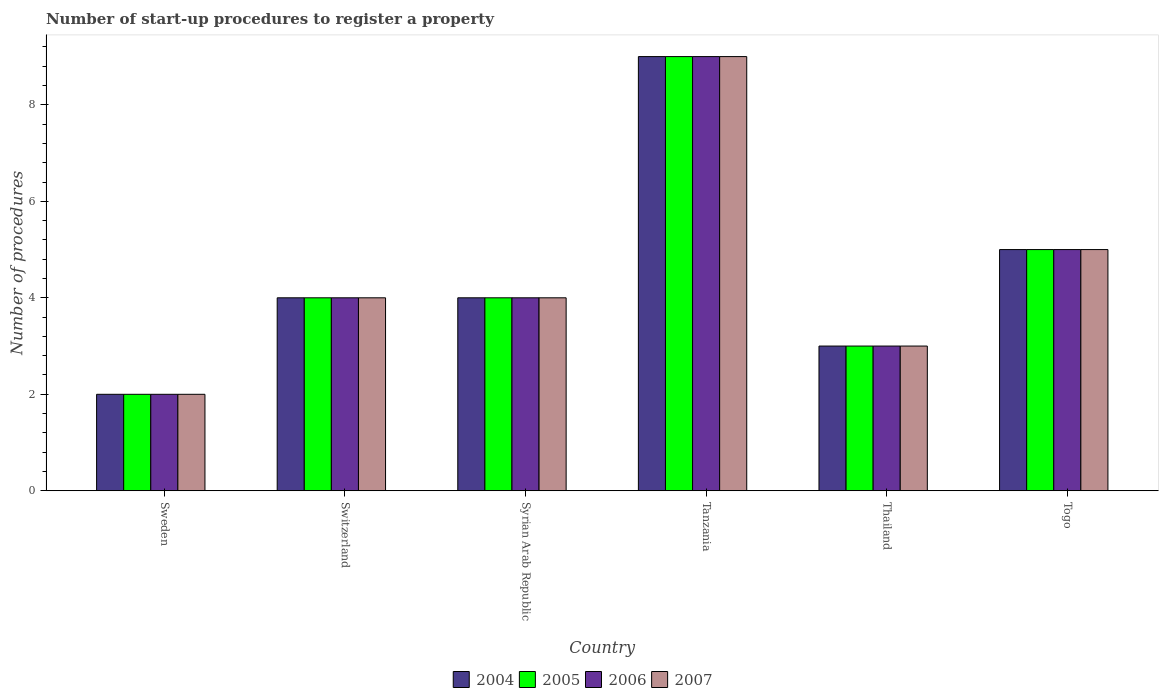Are the number of bars on each tick of the X-axis equal?
Provide a succinct answer. Yes. How many bars are there on the 3rd tick from the right?
Give a very brief answer. 4. What is the number of procedures required to register a property in 2004 in Sweden?
Keep it short and to the point. 2. In which country was the number of procedures required to register a property in 2006 maximum?
Keep it short and to the point. Tanzania. What is the difference between the number of procedures required to register a property in 2004 in Syrian Arab Republic and that in Tanzania?
Give a very brief answer. -5. What is the difference between the number of procedures required to register a property in 2007 in Tanzania and the number of procedures required to register a property in 2006 in Switzerland?
Your answer should be very brief. 5. What is the difference between the highest and the second highest number of procedures required to register a property in 2006?
Ensure brevity in your answer.  5. Is the sum of the number of procedures required to register a property in 2006 in Sweden and Thailand greater than the maximum number of procedures required to register a property in 2005 across all countries?
Keep it short and to the point. No. Is it the case that in every country, the sum of the number of procedures required to register a property in 2007 and number of procedures required to register a property in 2004 is greater than the sum of number of procedures required to register a property in 2006 and number of procedures required to register a property in 2005?
Make the answer very short. No. Is it the case that in every country, the sum of the number of procedures required to register a property in 2006 and number of procedures required to register a property in 2005 is greater than the number of procedures required to register a property in 2004?
Provide a short and direct response. Yes. How many countries are there in the graph?
Your response must be concise. 6. Does the graph contain any zero values?
Provide a succinct answer. No. Does the graph contain grids?
Ensure brevity in your answer.  No. Where does the legend appear in the graph?
Give a very brief answer. Bottom center. What is the title of the graph?
Make the answer very short. Number of start-up procedures to register a property. What is the label or title of the Y-axis?
Provide a succinct answer. Number of procedures. What is the Number of procedures in 2004 in Sweden?
Offer a terse response. 2. What is the Number of procedures in 2005 in Sweden?
Provide a succinct answer. 2. What is the Number of procedures of 2006 in Sweden?
Make the answer very short. 2. What is the Number of procedures of 2004 in Switzerland?
Give a very brief answer. 4. What is the Number of procedures of 2006 in Switzerland?
Keep it short and to the point. 4. What is the Number of procedures of 2007 in Switzerland?
Offer a very short reply. 4. What is the Number of procedures in 2007 in Syrian Arab Republic?
Provide a short and direct response. 4. What is the Number of procedures of 2007 in Tanzania?
Keep it short and to the point. 9. What is the Number of procedures in 2004 in Thailand?
Keep it short and to the point. 3. What is the Number of procedures in 2005 in Thailand?
Provide a short and direct response. 3. What is the Number of procedures of 2005 in Togo?
Provide a short and direct response. 5. What is the Number of procedures in 2006 in Togo?
Provide a short and direct response. 5. What is the Number of procedures in 2007 in Togo?
Provide a short and direct response. 5. Across all countries, what is the maximum Number of procedures of 2004?
Ensure brevity in your answer.  9. Across all countries, what is the maximum Number of procedures in 2006?
Keep it short and to the point. 9. Across all countries, what is the minimum Number of procedures of 2004?
Your answer should be very brief. 2. Across all countries, what is the minimum Number of procedures of 2006?
Your answer should be very brief. 2. Across all countries, what is the minimum Number of procedures in 2007?
Provide a succinct answer. 2. What is the total Number of procedures of 2004 in the graph?
Provide a short and direct response. 27. What is the total Number of procedures of 2006 in the graph?
Give a very brief answer. 27. What is the difference between the Number of procedures in 2004 in Sweden and that in Switzerland?
Offer a very short reply. -2. What is the difference between the Number of procedures in 2006 in Sweden and that in Switzerland?
Your answer should be compact. -2. What is the difference between the Number of procedures in 2006 in Sweden and that in Syrian Arab Republic?
Offer a very short reply. -2. What is the difference between the Number of procedures of 2007 in Sweden and that in Syrian Arab Republic?
Make the answer very short. -2. What is the difference between the Number of procedures of 2004 in Sweden and that in Tanzania?
Your answer should be very brief. -7. What is the difference between the Number of procedures in 2006 in Sweden and that in Tanzania?
Keep it short and to the point. -7. What is the difference between the Number of procedures in 2007 in Sweden and that in Tanzania?
Offer a very short reply. -7. What is the difference between the Number of procedures of 2004 in Sweden and that in Thailand?
Your answer should be very brief. -1. What is the difference between the Number of procedures in 2005 in Sweden and that in Thailand?
Give a very brief answer. -1. What is the difference between the Number of procedures in 2004 in Sweden and that in Togo?
Make the answer very short. -3. What is the difference between the Number of procedures of 2005 in Sweden and that in Togo?
Your response must be concise. -3. What is the difference between the Number of procedures of 2005 in Switzerland and that in Syrian Arab Republic?
Make the answer very short. 0. What is the difference between the Number of procedures in 2004 in Switzerland and that in Tanzania?
Provide a succinct answer. -5. What is the difference between the Number of procedures in 2004 in Switzerland and that in Thailand?
Ensure brevity in your answer.  1. What is the difference between the Number of procedures in 2005 in Switzerland and that in Thailand?
Your answer should be very brief. 1. What is the difference between the Number of procedures in 2006 in Switzerland and that in Thailand?
Offer a terse response. 1. What is the difference between the Number of procedures of 2004 in Switzerland and that in Togo?
Offer a very short reply. -1. What is the difference between the Number of procedures in 2005 in Switzerland and that in Togo?
Offer a very short reply. -1. What is the difference between the Number of procedures in 2006 in Switzerland and that in Togo?
Ensure brevity in your answer.  -1. What is the difference between the Number of procedures of 2004 in Syrian Arab Republic and that in Tanzania?
Your answer should be compact. -5. What is the difference between the Number of procedures of 2006 in Syrian Arab Republic and that in Tanzania?
Ensure brevity in your answer.  -5. What is the difference between the Number of procedures in 2005 in Syrian Arab Republic and that in Thailand?
Provide a succinct answer. 1. What is the difference between the Number of procedures in 2006 in Syrian Arab Republic and that in Thailand?
Offer a very short reply. 1. What is the difference between the Number of procedures of 2004 in Syrian Arab Republic and that in Togo?
Your response must be concise. -1. What is the difference between the Number of procedures of 2005 in Syrian Arab Republic and that in Togo?
Your answer should be very brief. -1. What is the difference between the Number of procedures in 2006 in Syrian Arab Republic and that in Togo?
Offer a terse response. -1. What is the difference between the Number of procedures in 2006 in Tanzania and that in Thailand?
Provide a succinct answer. 6. What is the difference between the Number of procedures of 2007 in Tanzania and that in Thailand?
Your response must be concise. 6. What is the difference between the Number of procedures of 2005 in Tanzania and that in Togo?
Your answer should be compact. 4. What is the difference between the Number of procedures in 2004 in Thailand and that in Togo?
Make the answer very short. -2. What is the difference between the Number of procedures in 2006 in Thailand and that in Togo?
Make the answer very short. -2. What is the difference between the Number of procedures in 2007 in Thailand and that in Togo?
Your response must be concise. -2. What is the difference between the Number of procedures of 2004 in Sweden and the Number of procedures of 2006 in Switzerland?
Offer a terse response. -2. What is the difference between the Number of procedures in 2004 in Sweden and the Number of procedures in 2007 in Switzerland?
Offer a terse response. -2. What is the difference between the Number of procedures of 2005 in Sweden and the Number of procedures of 2006 in Switzerland?
Ensure brevity in your answer.  -2. What is the difference between the Number of procedures of 2005 in Sweden and the Number of procedures of 2007 in Switzerland?
Make the answer very short. -2. What is the difference between the Number of procedures of 2004 in Sweden and the Number of procedures of 2005 in Syrian Arab Republic?
Ensure brevity in your answer.  -2. What is the difference between the Number of procedures in 2004 in Sweden and the Number of procedures in 2006 in Syrian Arab Republic?
Keep it short and to the point. -2. What is the difference between the Number of procedures in 2005 in Sweden and the Number of procedures in 2006 in Syrian Arab Republic?
Ensure brevity in your answer.  -2. What is the difference between the Number of procedures in 2005 in Sweden and the Number of procedures in 2007 in Syrian Arab Republic?
Keep it short and to the point. -2. What is the difference between the Number of procedures of 2006 in Sweden and the Number of procedures of 2007 in Syrian Arab Republic?
Your response must be concise. -2. What is the difference between the Number of procedures of 2004 in Sweden and the Number of procedures of 2006 in Tanzania?
Ensure brevity in your answer.  -7. What is the difference between the Number of procedures of 2005 in Sweden and the Number of procedures of 2006 in Tanzania?
Provide a short and direct response. -7. What is the difference between the Number of procedures of 2006 in Sweden and the Number of procedures of 2007 in Tanzania?
Give a very brief answer. -7. What is the difference between the Number of procedures of 2004 in Sweden and the Number of procedures of 2006 in Thailand?
Provide a short and direct response. -1. What is the difference between the Number of procedures of 2005 in Sweden and the Number of procedures of 2006 in Thailand?
Keep it short and to the point. -1. What is the difference between the Number of procedures of 2005 in Sweden and the Number of procedures of 2007 in Thailand?
Give a very brief answer. -1. What is the difference between the Number of procedures in 2004 in Sweden and the Number of procedures in 2006 in Togo?
Provide a succinct answer. -3. What is the difference between the Number of procedures in 2005 in Sweden and the Number of procedures in 2006 in Togo?
Provide a succinct answer. -3. What is the difference between the Number of procedures of 2004 in Switzerland and the Number of procedures of 2005 in Syrian Arab Republic?
Give a very brief answer. 0. What is the difference between the Number of procedures in 2004 in Switzerland and the Number of procedures in 2007 in Syrian Arab Republic?
Give a very brief answer. 0. What is the difference between the Number of procedures in 2004 in Switzerland and the Number of procedures in 2007 in Tanzania?
Ensure brevity in your answer.  -5. What is the difference between the Number of procedures in 2005 in Switzerland and the Number of procedures in 2006 in Tanzania?
Provide a succinct answer. -5. What is the difference between the Number of procedures in 2006 in Switzerland and the Number of procedures in 2007 in Tanzania?
Make the answer very short. -5. What is the difference between the Number of procedures of 2004 in Switzerland and the Number of procedures of 2007 in Thailand?
Your answer should be very brief. 1. What is the difference between the Number of procedures of 2005 in Switzerland and the Number of procedures of 2006 in Thailand?
Ensure brevity in your answer.  1. What is the difference between the Number of procedures of 2004 in Switzerland and the Number of procedures of 2006 in Togo?
Offer a terse response. -1. What is the difference between the Number of procedures of 2005 in Switzerland and the Number of procedures of 2006 in Togo?
Offer a very short reply. -1. What is the difference between the Number of procedures of 2006 in Switzerland and the Number of procedures of 2007 in Togo?
Provide a short and direct response. -1. What is the difference between the Number of procedures of 2004 in Syrian Arab Republic and the Number of procedures of 2006 in Tanzania?
Provide a succinct answer. -5. What is the difference between the Number of procedures in 2005 in Syrian Arab Republic and the Number of procedures in 2007 in Tanzania?
Offer a very short reply. -5. What is the difference between the Number of procedures in 2006 in Syrian Arab Republic and the Number of procedures in 2007 in Tanzania?
Offer a terse response. -5. What is the difference between the Number of procedures in 2004 in Syrian Arab Republic and the Number of procedures in 2005 in Thailand?
Keep it short and to the point. 1. What is the difference between the Number of procedures of 2005 in Syrian Arab Republic and the Number of procedures of 2006 in Thailand?
Offer a very short reply. 1. What is the difference between the Number of procedures in 2005 in Syrian Arab Republic and the Number of procedures in 2007 in Thailand?
Make the answer very short. 1. What is the difference between the Number of procedures of 2006 in Syrian Arab Republic and the Number of procedures of 2007 in Thailand?
Your response must be concise. 1. What is the difference between the Number of procedures in 2004 in Syrian Arab Republic and the Number of procedures in 2005 in Togo?
Your answer should be compact. -1. What is the difference between the Number of procedures of 2004 in Syrian Arab Republic and the Number of procedures of 2006 in Togo?
Provide a succinct answer. -1. What is the difference between the Number of procedures of 2005 in Syrian Arab Republic and the Number of procedures of 2007 in Togo?
Your response must be concise. -1. What is the difference between the Number of procedures in 2004 in Tanzania and the Number of procedures in 2005 in Thailand?
Your answer should be compact. 6. What is the difference between the Number of procedures of 2004 in Tanzania and the Number of procedures of 2006 in Thailand?
Provide a succinct answer. 6. What is the difference between the Number of procedures of 2005 in Tanzania and the Number of procedures of 2006 in Thailand?
Offer a very short reply. 6. What is the difference between the Number of procedures of 2006 in Tanzania and the Number of procedures of 2007 in Thailand?
Give a very brief answer. 6. What is the difference between the Number of procedures in 2004 in Tanzania and the Number of procedures in 2005 in Togo?
Offer a terse response. 4. What is the difference between the Number of procedures in 2004 in Tanzania and the Number of procedures in 2006 in Togo?
Provide a short and direct response. 4. What is the difference between the Number of procedures in 2005 in Tanzania and the Number of procedures in 2006 in Togo?
Offer a very short reply. 4. What is the difference between the Number of procedures of 2005 in Tanzania and the Number of procedures of 2007 in Togo?
Keep it short and to the point. 4. What is the difference between the Number of procedures of 2004 in Thailand and the Number of procedures of 2005 in Togo?
Ensure brevity in your answer.  -2. What is the difference between the Number of procedures in 2004 in Thailand and the Number of procedures in 2006 in Togo?
Offer a terse response. -2. What is the difference between the Number of procedures in 2005 in Thailand and the Number of procedures in 2007 in Togo?
Your answer should be very brief. -2. What is the difference between the Number of procedures of 2006 in Thailand and the Number of procedures of 2007 in Togo?
Keep it short and to the point. -2. What is the average Number of procedures of 2005 per country?
Provide a succinct answer. 4.5. What is the difference between the Number of procedures of 2005 and Number of procedures of 2006 in Sweden?
Offer a very short reply. 0. What is the difference between the Number of procedures of 2005 and Number of procedures of 2007 in Sweden?
Provide a short and direct response. 0. What is the difference between the Number of procedures in 2004 and Number of procedures in 2005 in Switzerland?
Make the answer very short. 0. What is the difference between the Number of procedures of 2004 and Number of procedures of 2006 in Switzerland?
Provide a short and direct response. 0. What is the difference between the Number of procedures in 2004 and Number of procedures in 2007 in Switzerland?
Provide a short and direct response. 0. What is the difference between the Number of procedures of 2005 and Number of procedures of 2006 in Switzerland?
Provide a succinct answer. 0. What is the difference between the Number of procedures of 2005 and Number of procedures of 2007 in Switzerland?
Make the answer very short. 0. What is the difference between the Number of procedures in 2004 and Number of procedures in 2005 in Syrian Arab Republic?
Offer a terse response. 0. What is the difference between the Number of procedures of 2004 and Number of procedures of 2006 in Syrian Arab Republic?
Offer a terse response. 0. What is the difference between the Number of procedures of 2004 and Number of procedures of 2007 in Syrian Arab Republic?
Provide a succinct answer. 0. What is the difference between the Number of procedures in 2005 and Number of procedures in 2006 in Syrian Arab Republic?
Ensure brevity in your answer.  0. What is the difference between the Number of procedures in 2005 and Number of procedures in 2007 in Syrian Arab Republic?
Offer a very short reply. 0. What is the difference between the Number of procedures in 2006 and Number of procedures in 2007 in Syrian Arab Republic?
Ensure brevity in your answer.  0. What is the difference between the Number of procedures in 2004 and Number of procedures in 2005 in Tanzania?
Your response must be concise. 0. What is the difference between the Number of procedures in 2004 and Number of procedures in 2006 in Tanzania?
Your response must be concise. 0. What is the difference between the Number of procedures in 2004 and Number of procedures in 2007 in Tanzania?
Offer a terse response. 0. What is the difference between the Number of procedures in 2005 and Number of procedures in 2006 in Tanzania?
Offer a very short reply. 0. What is the difference between the Number of procedures of 2004 and Number of procedures of 2005 in Thailand?
Ensure brevity in your answer.  0. What is the difference between the Number of procedures of 2004 and Number of procedures of 2007 in Thailand?
Give a very brief answer. 0. What is the difference between the Number of procedures in 2004 and Number of procedures in 2005 in Togo?
Ensure brevity in your answer.  0. What is the difference between the Number of procedures of 2004 and Number of procedures of 2007 in Togo?
Your answer should be very brief. 0. What is the difference between the Number of procedures of 2006 and Number of procedures of 2007 in Togo?
Provide a succinct answer. 0. What is the ratio of the Number of procedures of 2004 in Sweden to that in Switzerland?
Your answer should be very brief. 0.5. What is the ratio of the Number of procedures in 2005 in Sweden to that in Switzerland?
Provide a succinct answer. 0.5. What is the ratio of the Number of procedures of 2006 in Sweden to that in Switzerland?
Offer a very short reply. 0.5. What is the ratio of the Number of procedures in 2007 in Sweden to that in Switzerland?
Your answer should be compact. 0.5. What is the ratio of the Number of procedures in 2004 in Sweden to that in Syrian Arab Republic?
Your answer should be compact. 0.5. What is the ratio of the Number of procedures in 2005 in Sweden to that in Syrian Arab Republic?
Provide a short and direct response. 0.5. What is the ratio of the Number of procedures of 2006 in Sweden to that in Syrian Arab Republic?
Keep it short and to the point. 0.5. What is the ratio of the Number of procedures of 2004 in Sweden to that in Tanzania?
Provide a short and direct response. 0.22. What is the ratio of the Number of procedures of 2005 in Sweden to that in Tanzania?
Offer a very short reply. 0.22. What is the ratio of the Number of procedures of 2006 in Sweden to that in Tanzania?
Give a very brief answer. 0.22. What is the ratio of the Number of procedures in 2007 in Sweden to that in Tanzania?
Ensure brevity in your answer.  0.22. What is the ratio of the Number of procedures in 2004 in Sweden to that in Thailand?
Make the answer very short. 0.67. What is the ratio of the Number of procedures of 2005 in Sweden to that in Thailand?
Offer a very short reply. 0.67. What is the ratio of the Number of procedures in 2004 in Sweden to that in Togo?
Offer a very short reply. 0.4. What is the ratio of the Number of procedures of 2005 in Sweden to that in Togo?
Provide a succinct answer. 0.4. What is the ratio of the Number of procedures in 2006 in Sweden to that in Togo?
Your answer should be very brief. 0.4. What is the ratio of the Number of procedures in 2007 in Sweden to that in Togo?
Your answer should be compact. 0.4. What is the ratio of the Number of procedures in 2006 in Switzerland to that in Syrian Arab Republic?
Give a very brief answer. 1. What is the ratio of the Number of procedures of 2007 in Switzerland to that in Syrian Arab Republic?
Offer a terse response. 1. What is the ratio of the Number of procedures of 2004 in Switzerland to that in Tanzania?
Your answer should be compact. 0.44. What is the ratio of the Number of procedures of 2005 in Switzerland to that in Tanzania?
Offer a very short reply. 0.44. What is the ratio of the Number of procedures in 2006 in Switzerland to that in Tanzania?
Make the answer very short. 0.44. What is the ratio of the Number of procedures of 2007 in Switzerland to that in Tanzania?
Offer a very short reply. 0.44. What is the ratio of the Number of procedures of 2004 in Switzerland to that in Thailand?
Ensure brevity in your answer.  1.33. What is the ratio of the Number of procedures of 2007 in Switzerland to that in Thailand?
Offer a terse response. 1.33. What is the ratio of the Number of procedures in 2004 in Switzerland to that in Togo?
Provide a succinct answer. 0.8. What is the ratio of the Number of procedures in 2005 in Switzerland to that in Togo?
Ensure brevity in your answer.  0.8. What is the ratio of the Number of procedures of 2006 in Switzerland to that in Togo?
Your response must be concise. 0.8. What is the ratio of the Number of procedures in 2004 in Syrian Arab Republic to that in Tanzania?
Keep it short and to the point. 0.44. What is the ratio of the Number of procedures in 2005 in Syrian Arab Republic to that in Tanzania?
Give a very brief answer. 0.44. What is the ratio of the Number of procedures of 2006 in Syrian Arab Republic to that in Tanzania?
Provide a succinct answer. 0.44. What is the ratio of the Number of procedures in 2007 in Syrian Arab Republic to that in Tanzania?
Offer a very short reply. 0.44. What is the ratio of the Number of procedures in 2004 in Syrian Arab Republic to that in Togo?
Give a very brief answer. 0.8. What is the ratio of the Number of procedures of 2007 in Syrian Arab Republic to that in Togo?
Your answer should be very brief. 0.8. What is the ratio of the Number of procedures in 2004 in Tanzania to that in Thailand?
Your answer should be very brief. 3. What is the ratio of the Number of procedures in 2004 in Tanzania to that in Togo?
Offer a very short reply. 1.8. What is the ratio of the Number of procedures in 2006 in Tanzania to that in Togo?
Your answer should be very brief. 1.8. What is the ratio of the Number of procedures of 2007 in Tanzania to that in Togo?
Offer a terse response. 1.8. What is the ratio of the Number of procedures in 2004 in Thailand to that in Togo?
Provide a short and direct response. 0.6. What is the ratio of the Number of procedures in 2007 in Thailand to that in Togo?
Your response must be concise. 0.6. What is the difference between the highest and the second highest Number of procedures in 2004?
Provide a succinct answer. 4. What is the difference between the highest and the lowest Number of procedures in 2004?
Give a very brief answer. 7. What is the difference between the highest and the lowest Number of procedures in 2005?
Provide a succinct answer. 7. What is the difference between the highest and the lowest Number of procedures in 2007?
Your answer should be compact. 7. 